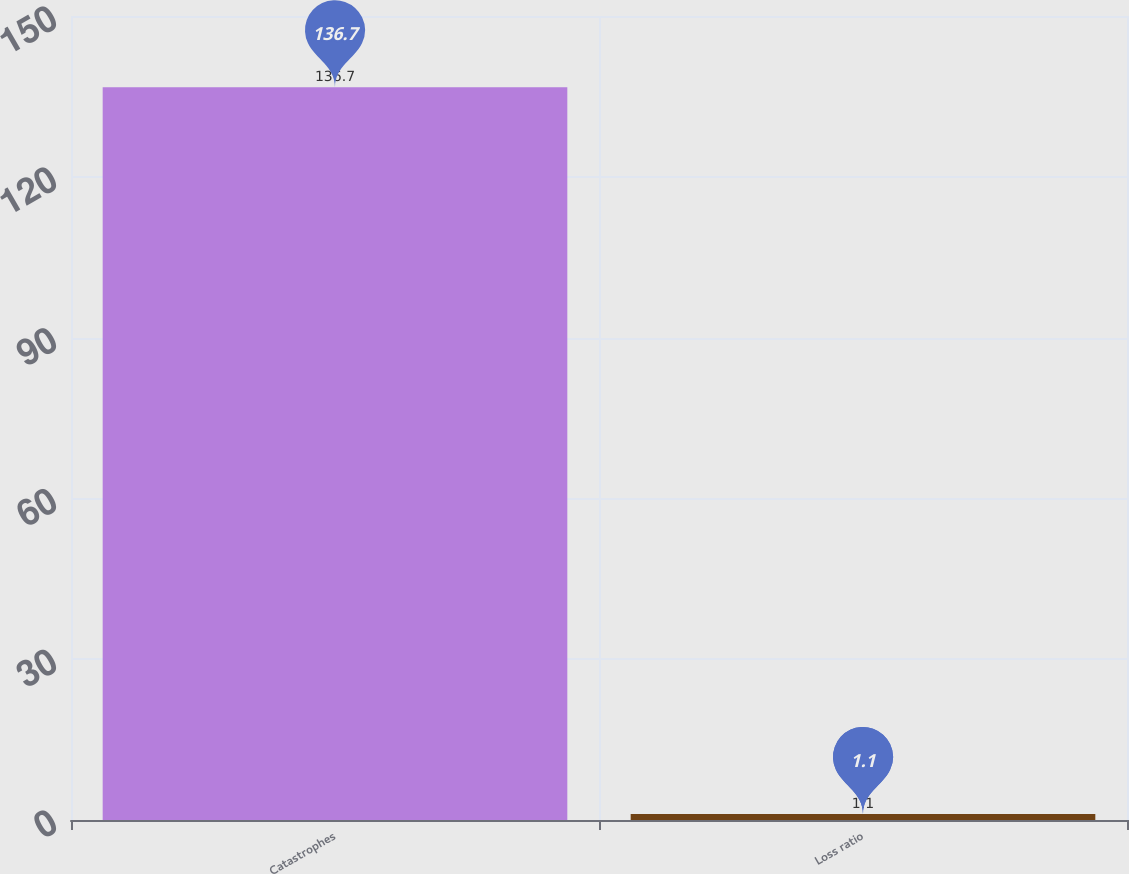<chart> <loc_0><loc_0><loc_500><loc_500><bar_chart><fcel>Catastrophes<fcel>Loss ratio<nl><fcel>136.7<fcel>1.1<nl></chart> 